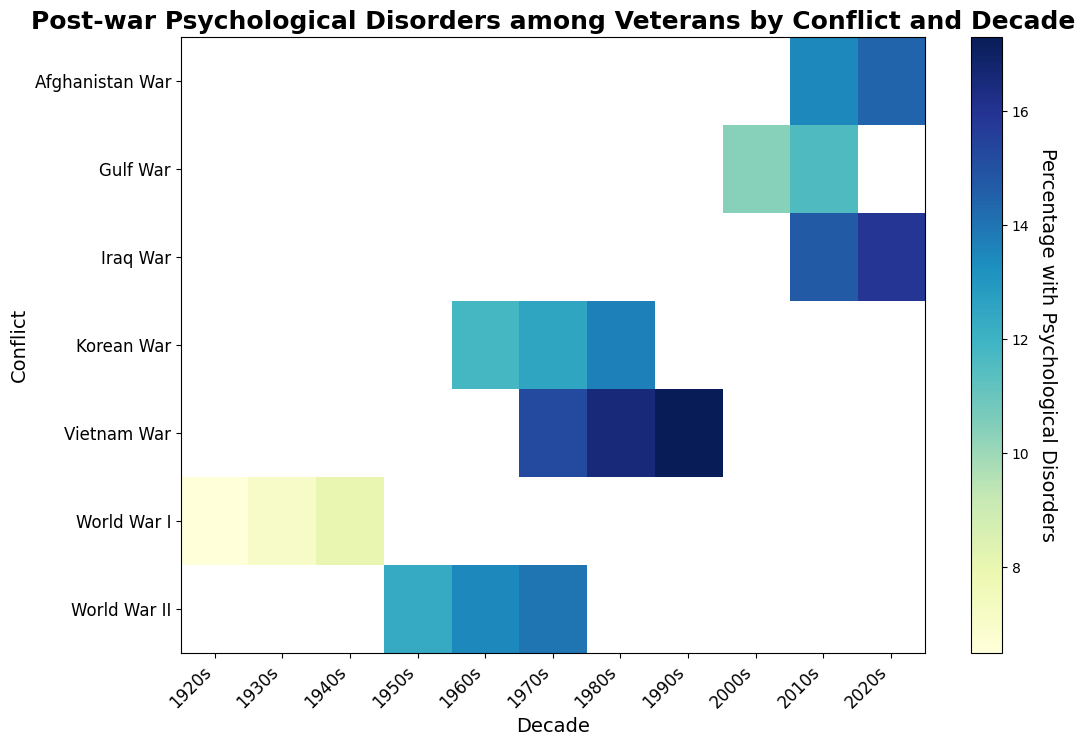What conflict in the 2010s has the highest percentage of veterans with psychological disorders? Looking at the heatmap for the 2010s column, the color intensity representing the highest value is seen in the row corresponding to the Iraq War.
Answer: Iraq War Which conflict experienced the greatest increase in the percentage of psychological disorders from its earliest to latest decade represented? For each conflict, look at the difference between the percentage values in their first and last decades. The Vietnam War starts in the 1970s with 15.2% and increases to 17.3% in the 1990s. Comparatively, the Iraq War starts in the 2010s with 14.7% and increases to 15.9% in the 2020s, which shows a smaller increase. The Vietnam War has the largest increase.
Answer: Vietnam War What is the average percentage of psychological disorders among veterans of the World War II recorded in the figure? Add the percentages for World War II (12.3, 13.5, and 14.0) and divide by the number of decades (3). The total is 39.8, and the average is 39.8 / 3.
Answer: 13.27% Is the percentage of psychological disorders among Vietnam War veterans in the 1980s higher or lower than among World War II veterans in the 1960s? Compare the values found in the heatmap for Vietnam War in the 1980s (16.5) and World War II in the 1960s (13.5). The former is larger.
Answer: Higher How does the percentage of psychological disorders among Korean War veterans in the 1970s compare to that of Gulf War veterans in the 2000s? Look at the corresponding values in the heatmap for the 1970s Korean War (12.5) and 2000s Gulf War (10.4). The former value is greater than the latter.
Answer: Higher What is the difference in the percentages of psychological disorders between veterans of the Afghanistan War in the 2010s and 2020s? Subtract the value in the 2010s (13.5) from the value in the 2020s (14.4). The difference is 14.4 - 13.5.
Answer: 0.9 Which conflict has the least variation in the percentage of psychological disorders among its veterans? Calculate the range for each conflict by subtracting the smallest percentage from the largest percentage for each conflict. The World War I numbers vary from 6.5 to 8.0 (a range of 1.5), which is the least among the conflicts.
Answer: World War I Which decade observes the largest range in percentages of psychological disorders across all conflicts? Compare the differences between the highest and lowest percentage values in each decade. The 2020s range from 14.4 (Afghanistan War) to 15.9 (Iraq War), a range of 1.5. The 1970s range from 12.5 (Korean War) to 15.2 (Vietnam War), a range of 2.7. The largest range is seen in the 1970s with 2.7.
Answer: 1970s What is the median percentage of psychological disorders among veterans of the conflicts listed for the 1960s? The percentages in the 1960s are for World War II (13.5) and Korean War (11.8). Arrange them to get (11.8, 13.5). The median is the average of the middle two numbers, which is (11.8 + 13.5)/2.
Answer: 12.65 